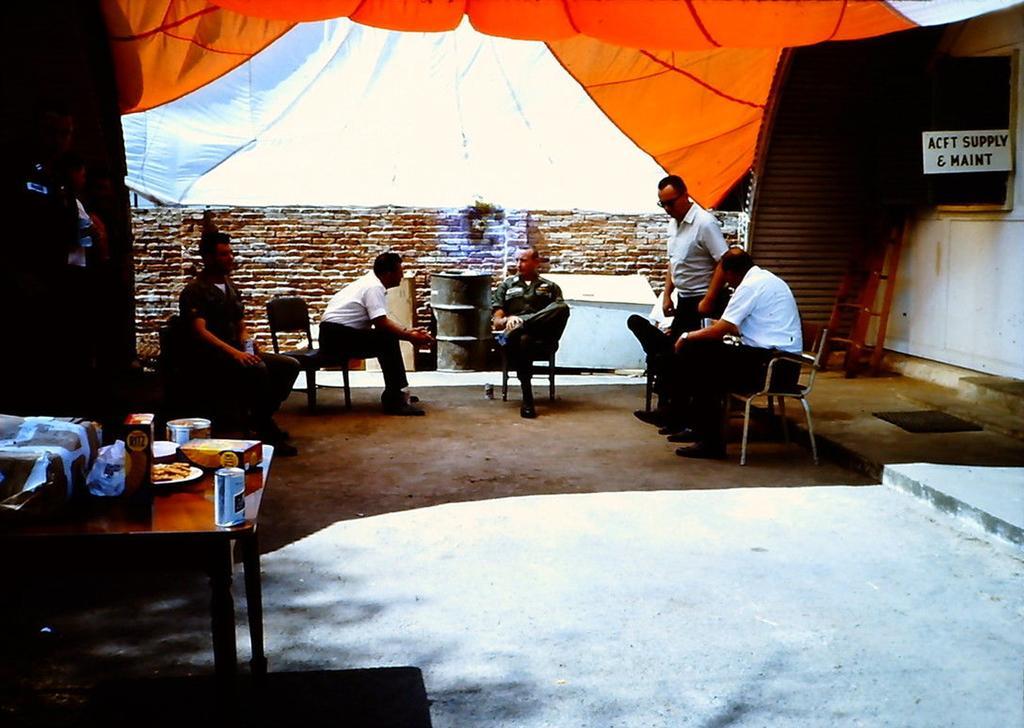How would you summarize this image in a sentence or two? In this image I see 4 men who are sitting on the chair and I see another men who is standing on the floor. I can also see there are few things on the table. In the background I see the wall and the clothes. 